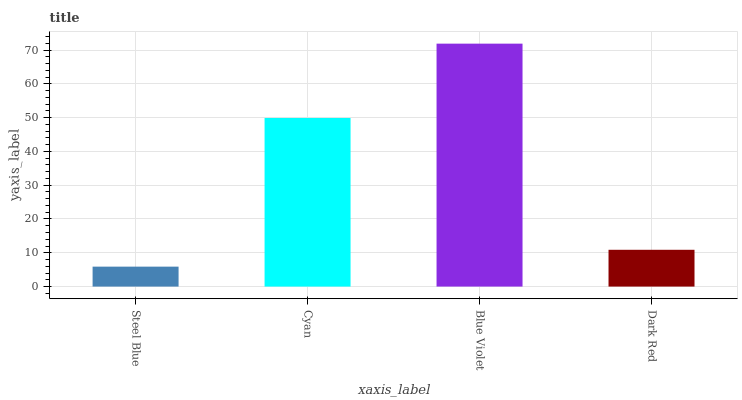Is Cyan the minimum?
Answer yes or no. No. Is Cyan the maximum?
Answer yes or no. No. Is Cyan greater than Steel Blue?
Answer yes or no. Yes. Is Steel Blue less than Cyan?
Answer yes or no. Yes. Is Steel Blue greater than Cyan?
Answer yes or no. No. Is Cyan less than Steel Blue?
Answer yes or no. No. Is Cyan the high median?
Answer yes or no. Yes. Is Dark Red the low median?
Answer yes or no. Yes. Is Dark Red the high median?
Answer yes or no. No. Is Blue Violet the low median?
Answer yes or no. No. 